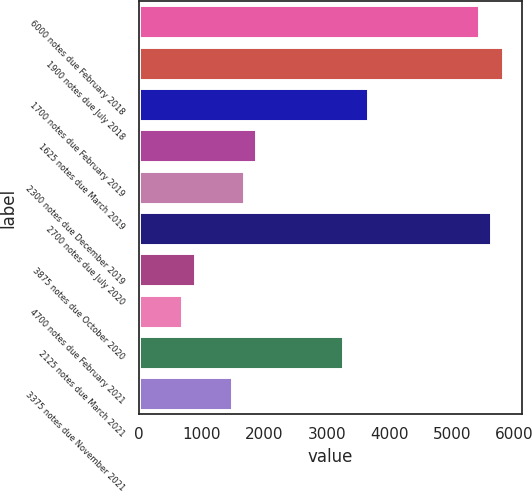Convert chart to OTSL. <chart><loc_0><loc_0><loc_500><loc_500><bar_chart><fcel>6000 notes due February 2018<fcel>1900 notes due July 2018<fcel>1700 notes due February 2019<fcel>1625 notes due March 2019<fcel>2300 notes due December 2019<fcel>2700 notes due July 2020<fcel>3875 notes due October 2020<fcel>4700 notes due February 2021<fcel>2125 notes due March 2021<fcel>3375 notes due November 2021<nl><fcel>5431<fcel>5826<fcel>3653.5<fcel>1876<fcel>1678.5<fcel>5628.5<fcel>888.5<fcel>691<fcel>3258.5<fcel>1481<nl></chart> 